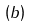<formula> <loc_0><loc_0><loc_500><loc_500>\left ( b \right )</formula> 